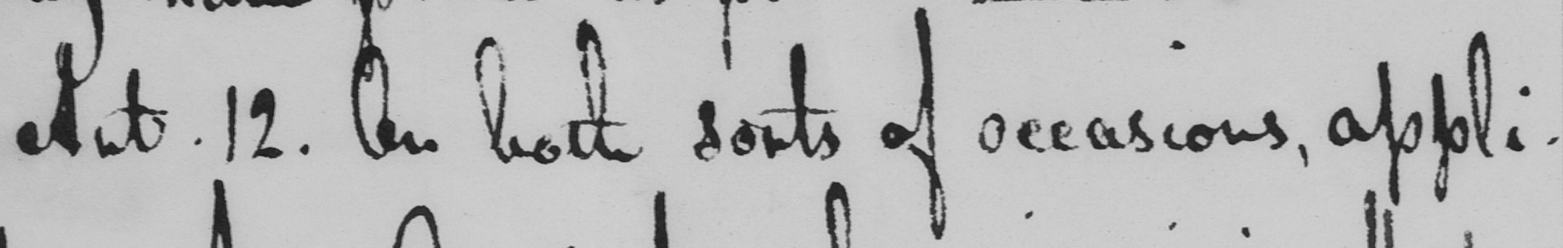Please provide the text content of this handwritten line. Art . 12 . On both sorts of occasions , appli- 